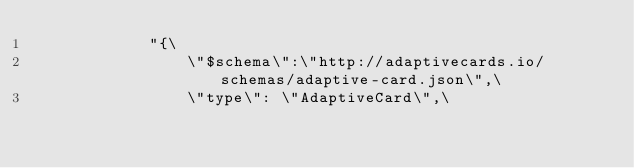<code> <loc_0><loc_0><loc_500><loc_500><_C++_>            "{\
                \"$schema\":\"http://adaptivecards.io/schemas/adaptive-card.json\",\
                \"type\": \"AdaptiveCard\",\</code> 